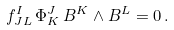<formula> <loc_0><loc_0><loc_500><loc_500>f ^ { I } _ { J L } \, \Phi ^ { J } _ { K } \, B ^ { K } \wedge B ^ { L } = 0 \, .</formula> 